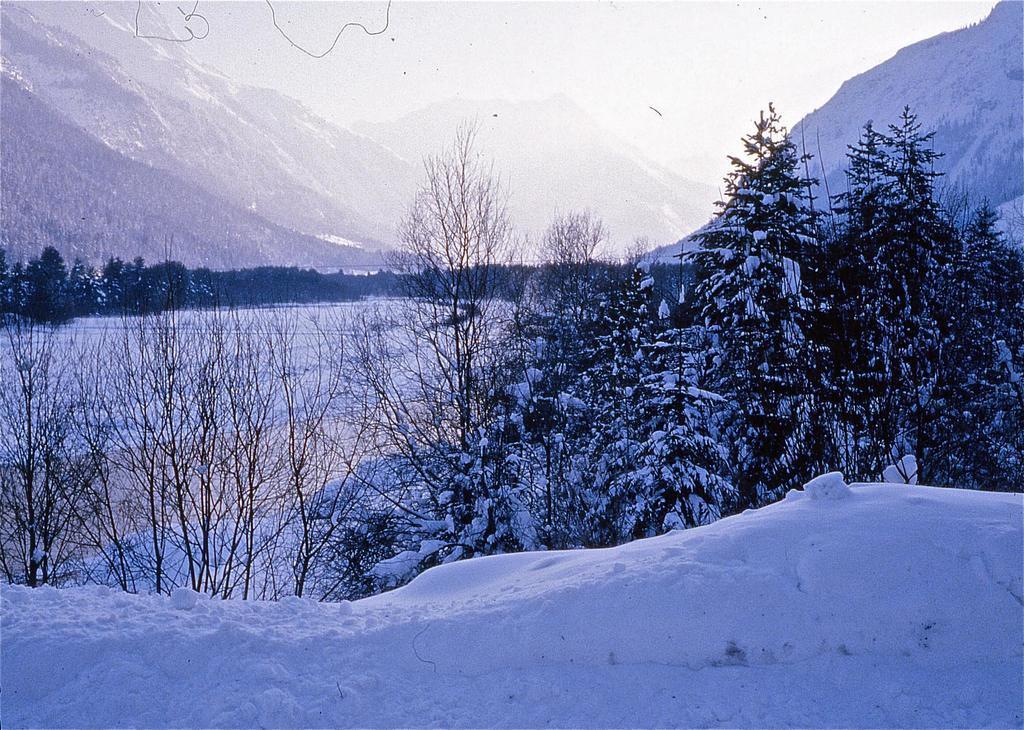Could you give a brief overview of what you see in this image? in the given image i can see a ice land and i can few trees after that i can see trees which are dried few trees which is filled with ice and i can see mountains. 